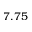<formula> <loc_0><loc_0><loc_500><loc_500>7 . 7 5</formula> 